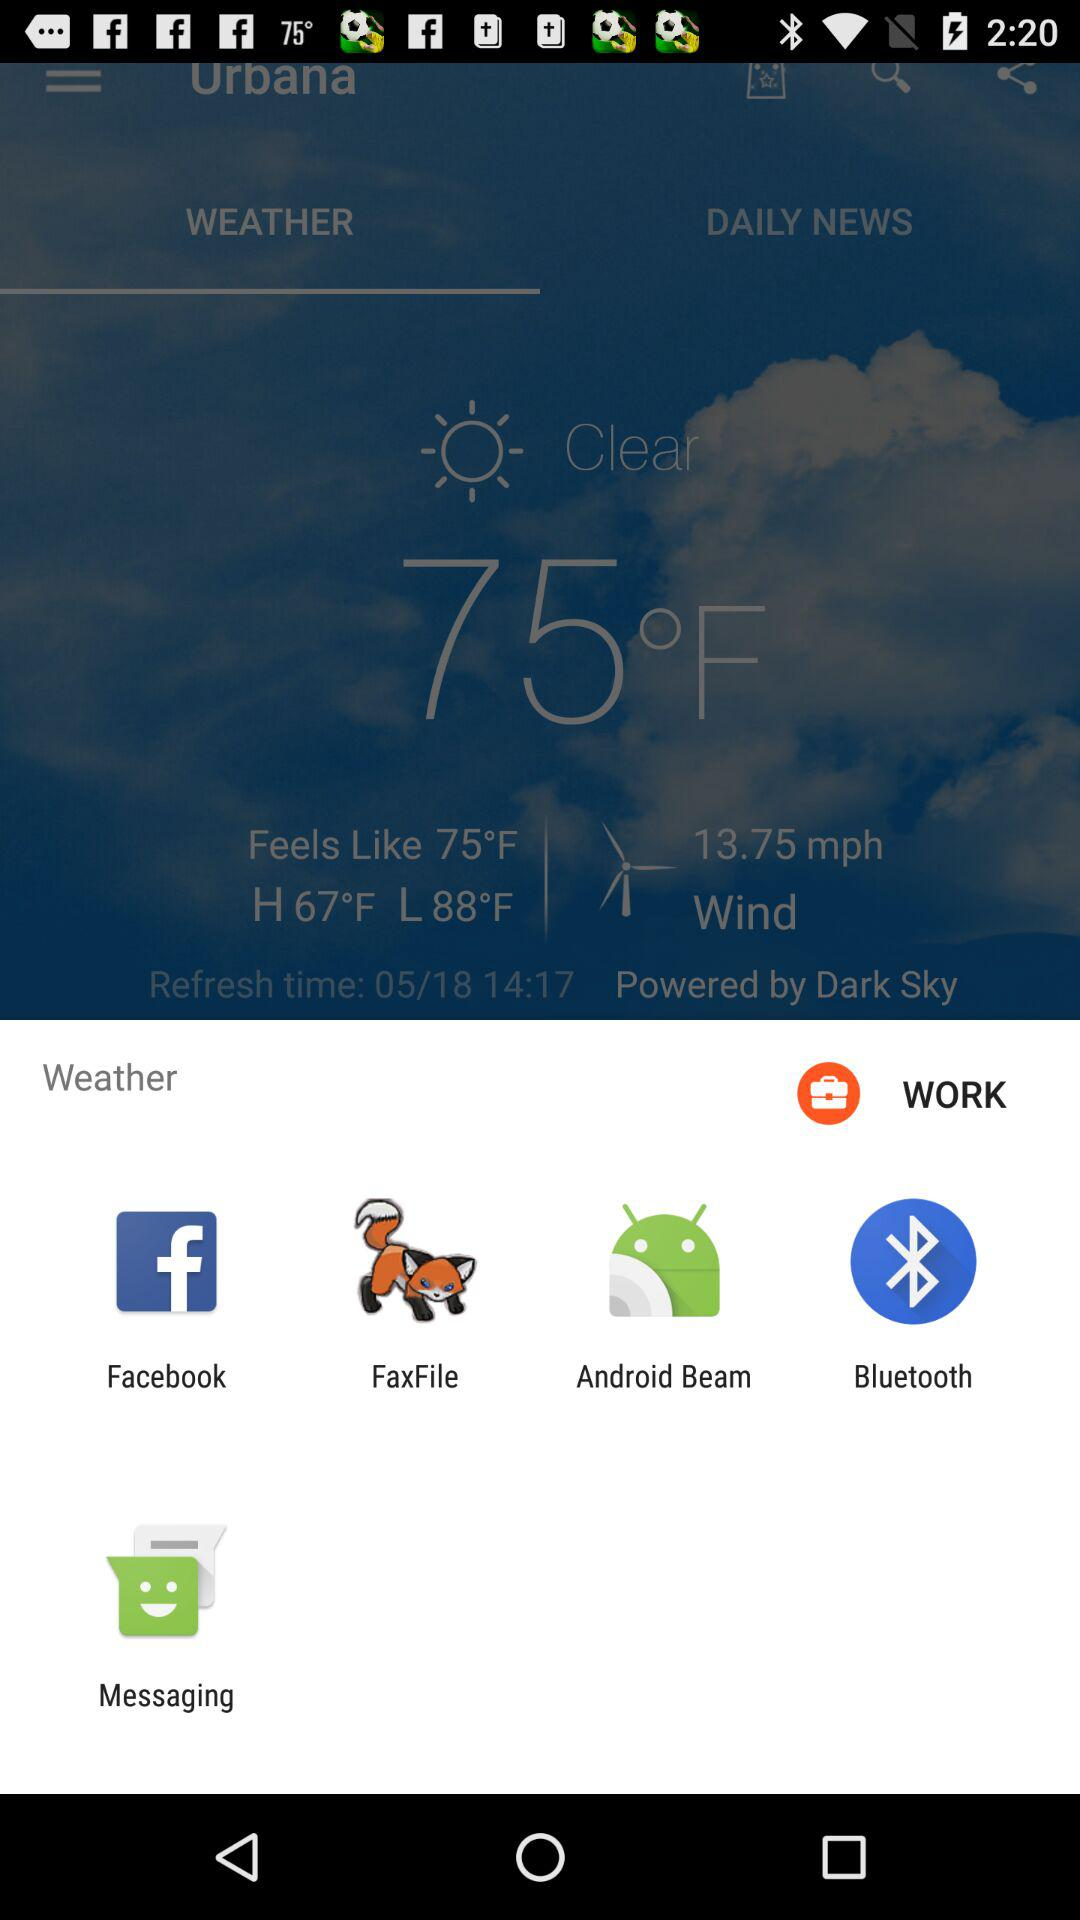What is the temperature in Fahrenheit? The temperature in Fahrenheit is 75°. 